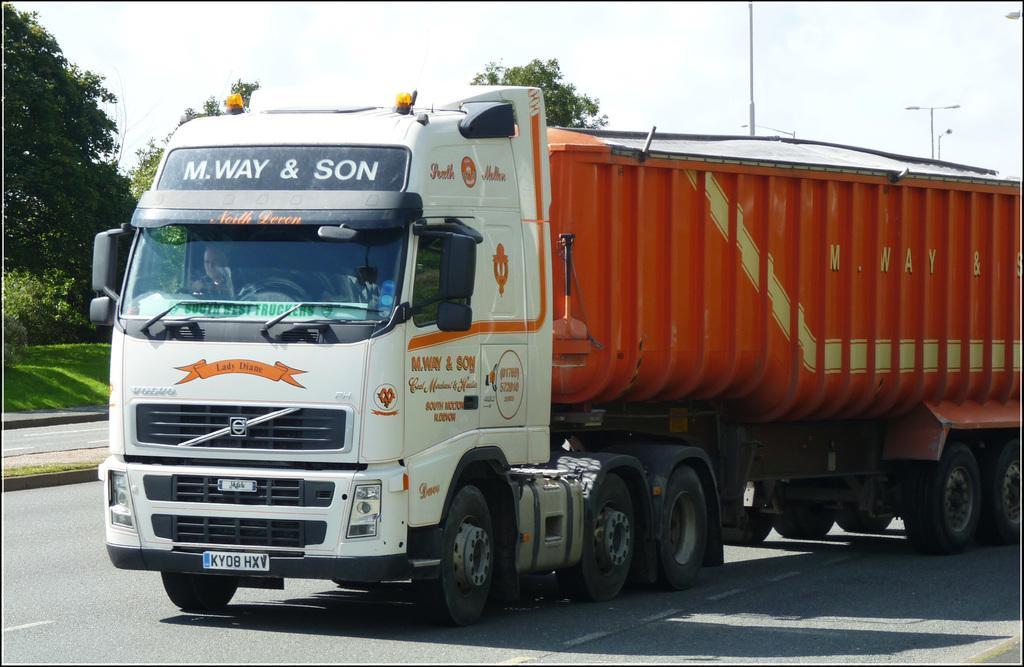In one or two sentences, can you explain what this image depicts? In this picture we can observe a lorry on the road. This lorry is in white and orange color. In the background we can observe trees, poles and a sky with some clouds. 